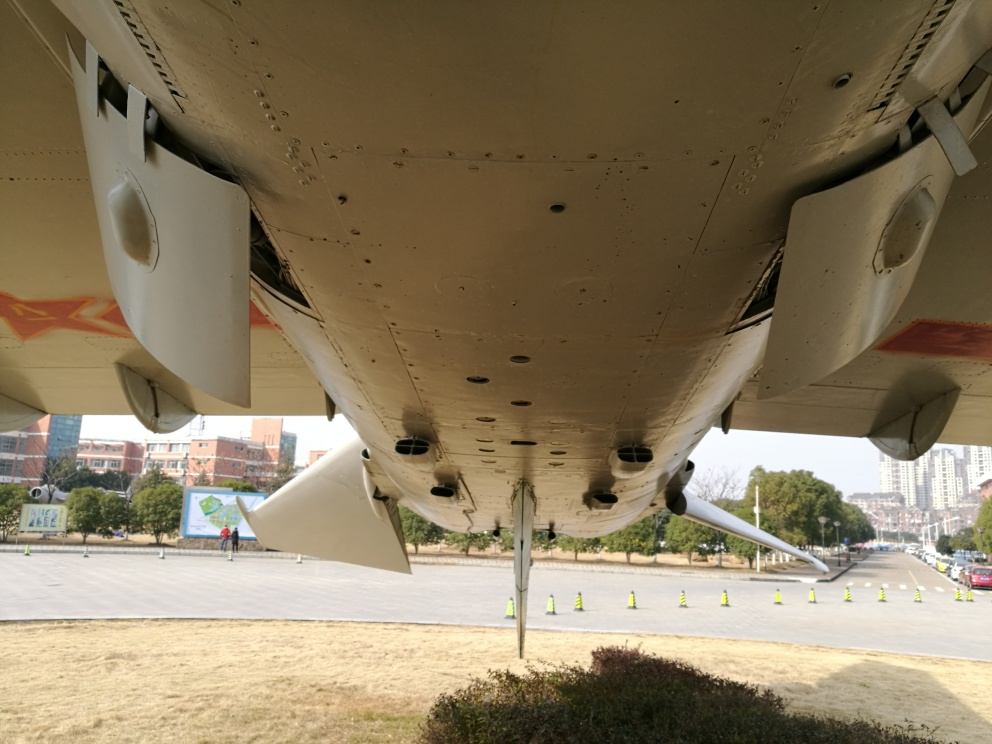What type of aircraft is pictured here? From the image, it appears to be a commercial jetliner, identified by its large size, winglets, and under-wing engines. Due to the angle and distance, the exact make and model cannot be determined. 